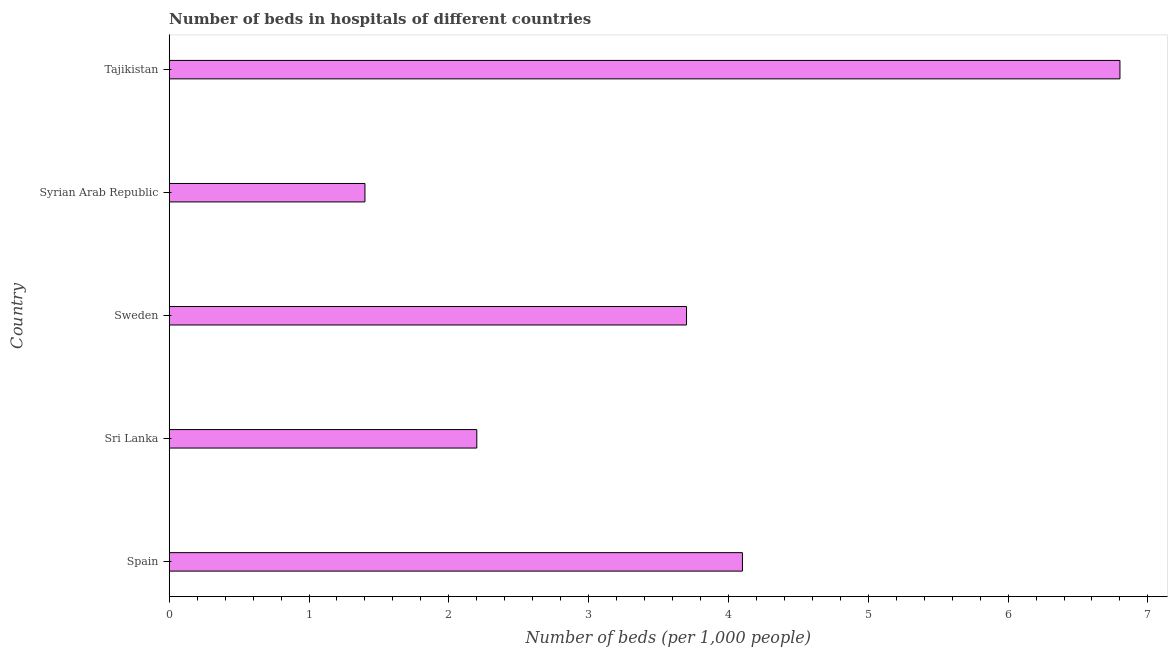Does the graph contain any zero values?
Your answer should be compact. No. What is the title of the graph?
Provide a short and direct response. Number of beds in hospitals of different countries. What is the label or title of the X-axis?
Make the answer very short. Number of beds (per 1,0 people). What is the number of hospital beds in Tajikistan?
Keep it short and to the point. 6.8. Across all countries, what is the maximum number of hospital beds?
Offer a very short reply. 6.8. Across all countries, what is the minimum number of hospital beds?
Keep it short and to the point. 1.4. In which country was the number of hospital beds maximum?
Your response must be concise. Tajikistan. In which country was the number of hospital beds minimum?
Offer a very short reply. Syrian Arab Republic. What is the sum of the number of hospital beds?
Offer a very short reply. 18.2. What is the difference between the number of hospital beds in Spain and Tajikistan?
Your answer should be very brief. -2.7. What is the average number of hospital beds per country?
Make the answer very short. 3.64. What is the median number of hospital beds?
Your response must be concise. 3.7. What is the ratio of the number of hospital beds in Syrian Arab Republic to that in Tajikistan?
Offer a very short reply. 0.21. Is the number of hospital beds in Sweden less than that in Tajikistan?
Make the answer very short. Yes. Is the difference between the number of hospital beds in Sweden and Tajikistan greater than the difference between any two countries?
Your response must be concise. No. What is the difference between the highest and the second highest number of hospital beds?
Provide a succinct answer. 2.7. Is the sum of the number of hospital beds in Spain and Sri Lanka greater than the maximum number of hospital beds across all countries?
Give a very brief answer. No. What is the difference between the highest and the lowest number of hospital beds?
Keep it short and to the point. 5.4. In how many countries, is the number of hospital beds greater than the average number of hospital beds taken over all countries?
Keep it short and to the point. 3. How many bars are there?
Provide a short and direct response. 5. Are all the bars in the graph horizontal?
Make the answer very short. Yes. What is the Number of beds (per 1,000 people) of Spain?
Offer a very short reply. 4.1. What is the Number of beds (per 1,000 people) in Sri Lanka?
Your response must be concise. 2.2. What is the Number of beds (per 1,000 people) of Sweden?
Ensure brevity in your answer.  3.7. What is the Number of beds (per 1,000 people) of Syrian Arab Republic?
Make the answer very short. 1.4. What is the Number of beds (per 1,000 people) of Tajikistan?
Make the answer very short. 6.8. What is the difference between the Number of beds (per 1,000 people) in Spain and Sweden?
Offer a terse response. 0.4. What is the difference between the Number of beds (per 1,000 people) in Spain and Syrian Arab Republic?
Your answer should be very brief. 2.7. What is the difference between the Number of beds (per 1,000 people) in Sri Lanka and Syrian Arab Republic?
Ensure brevity in your answer.  0.8. What is the difference between the Number of beds (per 1,000 people) in Sri Lanka and Tajikistan?
Your answer should be very brief. -4.6. What is the difference between the Number of beds (per 1,000 people) in Sweden and Syrian Arab Republic?
Offer a very short reply. 2.3. What is the difference between the Number of beds (per 1,000 people) in Syrian Arab Republic and Tajikistan?
Provide a short and direct response. -5.4. What is the ratio of the Number of beds (per 1,000 people) in Spain to that in Sri Lanka?
Ensure brevity in your answer.  1.86. What is the ratio of the Number of beds (per 1,000 people) in Spain to that in Sweden?
Your response must be concise. 1.11. What is the ratio of the Number of beds (per 1,000 people) in Spain to that in Syrian Arab Republic?
Provide a short and direct response. 2.93. What is the ratio of the Number of beds (per 1,000 people) in Spain to that in Tajikistan?
Ensure brevity in your answer.  0.6. What is the ratio of the Number of beds (per 1,000 people) in Sri Lanka to that in Sweden?
Provide a short and direct response. 0.59. What is the ratio of the Number of beds (per 1,000 people) in Sri Lanka to that in Syrian Arab Republic?
Offer a terse response. 1.57. What is the ratio of the Number of beds (per 1,000 people) in Sri Lanka to that in Tajikistan?
Your response must be concise. 0.32. What is the ratio of the Number of beds (per 1,000 people) in Sweden to that in Syrian Arab Republic?
Offer a terse response. 2.64. What is the ratio of the Number of beds (per 1,000 people) in Sweden to that in Tajikistan?
Offer a terse response. 0.54. What is the ratio of the Number of beds (per 1,000 people) in Syrian Arab Republic to that in Tajikistan?
Ensure brevity in your answer.  0.21. 